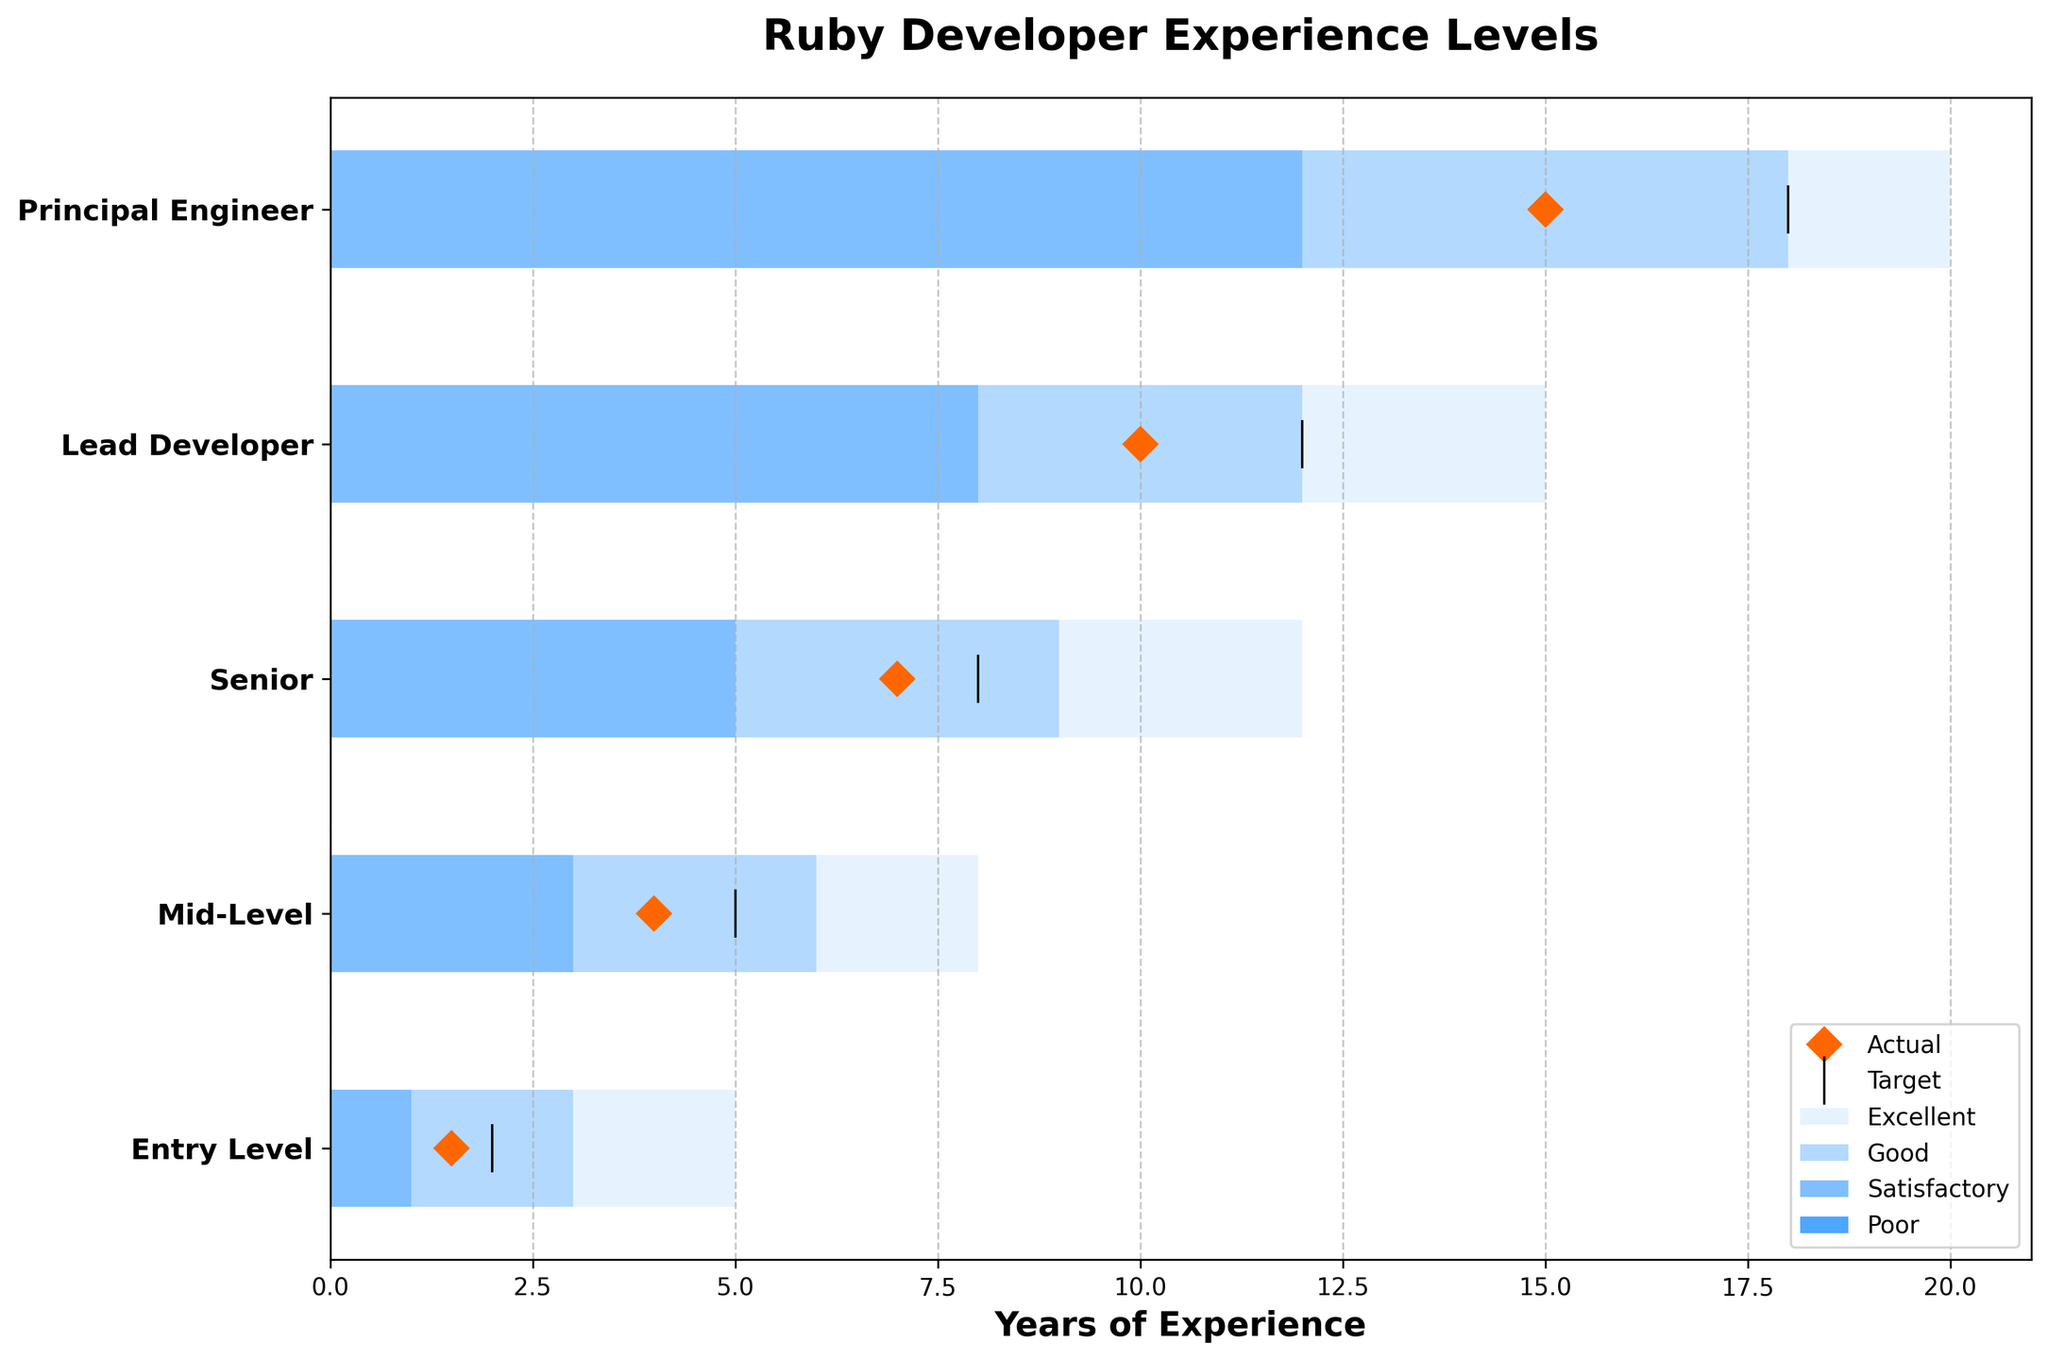What's the highest experience level displayed in the figure? The figure lists 'Principal Engineer' with 15 actual years of experience as the highest experience level.
Answer: Principal Engineer What color represents the 'Excellent' category in the bars? The 'Excellent' category is represented with the lightest shade of blue in the bars.
Answer: Lightest Shade of Blue What is the target number of years of experience for a Lead Developer? The figure shows a vertical line for the target value, and for a Lead Developer, this line is at 12 years of experience.
Answer: 12 years How does the actual experience of an Entry Level Ruby developer compare to the target experience? The actual experience for an Entry Level developer is shown as a diamond marker, which is 1.5 years, while the target is represented by a vertical line at 2 years, thus the actual is less than the target.
Answer: Less than the target Which experience level has the smallest gap between the target and actual years of experience? To determine the smallest gap, we compare the difference between the target and actual values for each experience level. Entry Level (0.5), Mid-Level (1), Senior (1), Lead Developer (2), Principal Engineer (3). The smallest gap is 0.5 years for Entry Level.
Answer: Entry Level What's the range of years considered 'Good' for a Senior Ruby developer? According to the bars in the figure, the range for 'Good' is indicated between 9 and 12 years of experience for a Senior Ruby developer.
Answer: 9-12 years Is the actual experience of Mid-Level Ruby developers within the 'Good' range? 'Good' range for Mid-Level is defined between 6-8 years. The actual experience for Mid-Level is 4 years, which is below the 'Good' range, placing it in the 'Poor' range.
Answer: No Which two experience levels have their actual experience in the 'Satisfactory' category? The 'Satisfactory' category ranges are filled with medium blue color; Entry Level's actual is within 1-3 and Mid-Level’s actual falls in the 3-6 range.
Answer: Entry Level and Mid-Level How much more experience does a Principal Engineer have compared to a Lead Developer? The actual experience for a Principal Engineer is 15 years, and for a Lead Developer, it is 10 years. Therefore, a Principal Engineer has 5 more years of experience.
Answer: 5 years What's the total of all target experience years shown in the figure? Adding target values for each level: 2 (Entry) + 5 (Mid-Level) + 8 (Senior) + 12 (Lead Developer) + 18 (Principal Engineer) = 45 years.
Answer: 45 years 